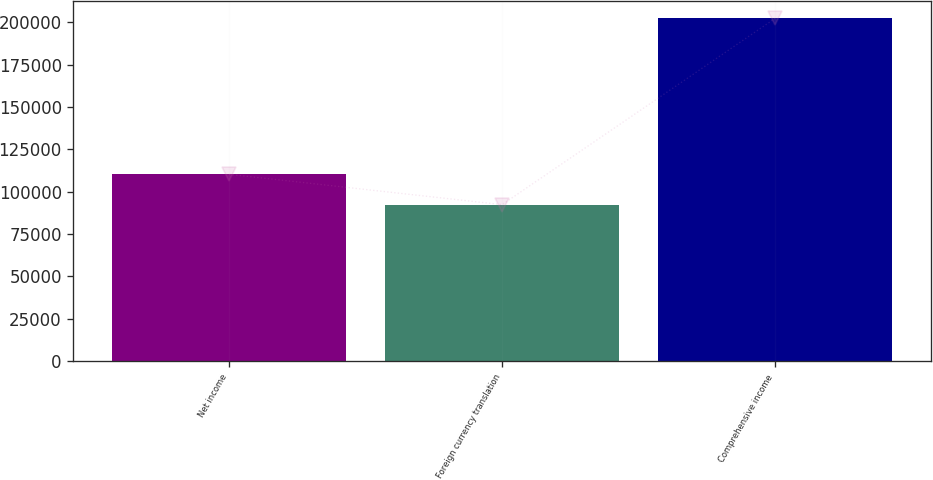<chart> <loc_0><loc_0><loc_500><loc_500><bar_chart><fcel>Net income<fcel>Foreign currency translation<fcel>Comprehensive income<nl><fcel>110303<fcel>92401<fcel>202319<nl></chart> 